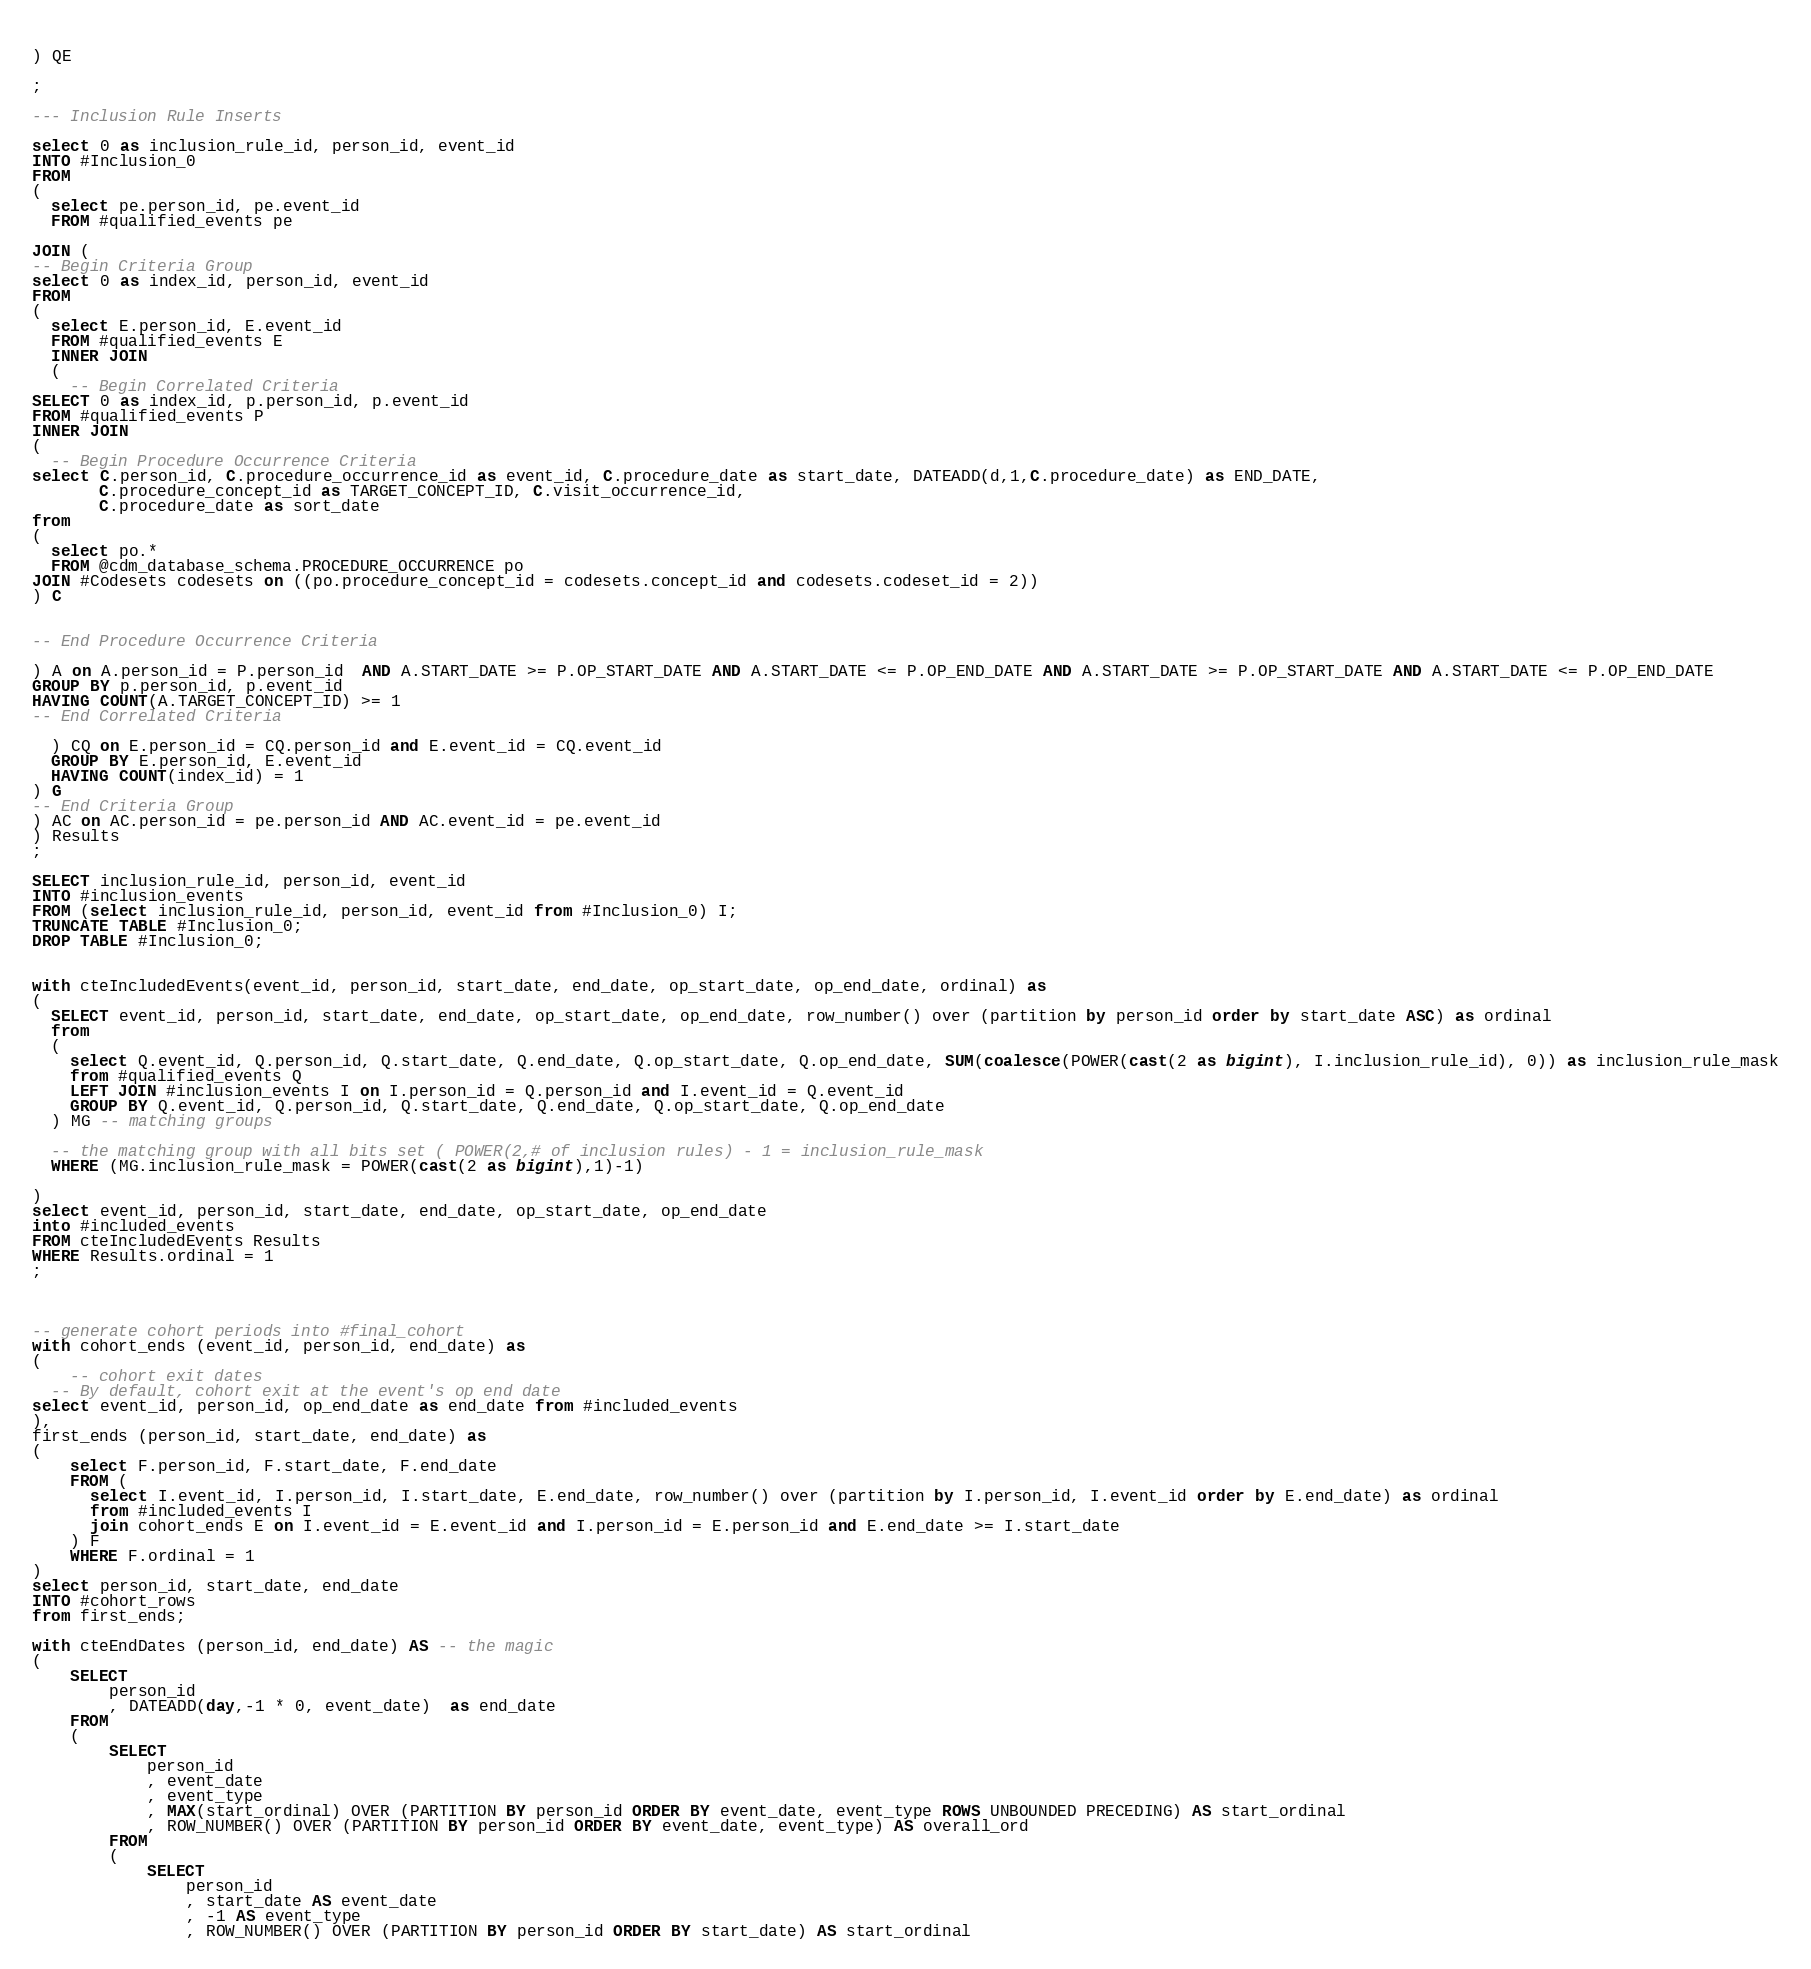Convert code to text. <code><loc_0><loc_0><loc_500><loc_500><_SQL_>  
) QE

;

--- Inclusion Rule Inserts

select 0 as inclusion_rule_id, person_id, event_id
INTO #Inclusion_0
FROM 
(
  select pe.person_id, pe.event_id
  FROM #qualified_events pe
  
JOIN (
-- Begin Criteria Group
select 0 as index_id, person_id, event_id
FROM
(
  select E.person_id, E.event_id 
  FROM #qualified_events E
  INNER JOIN
  (
    -- Begin Correlated Criteria
SELECT 0 as index_id, p.person_id, p.event_id
FROM #qualified_events P
INNER JOIN
(
  -- Begin Procedure Occurrence Criteria
select C.person_id, C.procedure_occurrence_id as event_id, C.procedure_date as start_date, DATEADD(d,1,C.procedure_date) as END_DATE,
       C.procedure_concept_id as TARGET_CONCEPT_ID, C.visit_occurrence_id,
       C.procedure_date as sort_date
from 
(
  select po.* 
  FROM @cdm_database_schema.PROCEDURE_OCCURRENCE po
JOIN #Codesets codesets on ((po.procedure_concept_id = codesets.concept_id and codesets.codeset_id = 2))
) C


-- End Procedure Occurrence Criteria

) A on A.person_id = P.person_id  AND A.START_DATE >= P.OP_START_DATE AND A.START_DATE <= P.OP_END_DATE AND A.START_DATE >= P.OP_START_DATE AND A.START_DATE <= P.OP_END_DATE
GROUP BY p.person_id, p.event_id
HAVING COUNT(A.TARGET_CONCEPT_ID) >= 1
-- End Correlated Criteria

  ) CQ on E.person_id = CQ.person_id and E.event_id = CQ.event_id
  GROUP BY E.person_id, E.event_id
  HAVING COUNT(index_id) = 1
) G
-- End Criteria Group
) AC on AC.person_id = pe.person_id AND AC.event_id = pe.event_id
) Results
;

SELECT inclusion_rule_id, person_id, event_id
INTO #inclusion_events
FROM (select inclusion_rule_id, person_id, event_id from #Inclusion_0) I;
TRUNCATE TABLE #Inclusion_0;
DROP TABLE #Inclusion_0;


with cteIncludedEvents(event_id, person_id, start_date, end_date, op_start_date, op_end_date, ordinal) as
(
  SELECT event_id, person_id, start_date, end_date, op_start_date, op_end_date, row_number() over (partition by person_id order by start_date ASC) as ordinal
  from
  (
    select Q.event_id, Q.person_id, Q.start_date, Q.end_date, Q.op_start_date, Q.op_end_date, SUM(coalesce(POWER(cast(2 as bigint), I.inclusion_rule_id), 0)) as inclusion_rule_mask
    from #qualified_events Q
    LEFT JOIN #inclusion_events I on I.person_id = Q.person_id and I.event_id = Q.event_id
    GROUP BY Q.event_id, Q.person_id, Q.start_date, Q.end_date, Q.op_start_date, Q.op_end_date
  ) MG -- matching groups

  -- the matching group with all bits set ( POWER(2,# of inclusion rules) - 1 = inclusion_rule_mask
  WHERE (MG.inclusion_rule_mask = POWER(cast(2 as bigint),1)-1)

)
select event_id, person_id, start_date, end_date, op_start_date, op_end_date
into #included_events
FROM cteIncludedEvents Results
WHERE Results.ordinal = 1
;



-- generate cohort periods into #final_cohort
with cohort_ends (event_id, person_id, end_date) as
(
	-- cohort exit dates
  -- By default, cohort exit at the event's op end date
select event_id, person_id, op_end_date as end_date from #included_events
),
first_ends (person_id, start_date, end_date) as
(
	select F.person_id, F.start_date, F.end_date
	FROM (
	  select I.event_id, I.person_id, I.start_date, E.end_date, row_number() over (partition by I.person_id, I.event_id order by E.end_date) as ordinal 
	  from #included_events I
	  join cohort_ends E on I.event_id = E.event_id and I.person_id = E.person_id and E.end_date >= I.start_date
	) F
	WHERE F.ordinal = 1
)
select person_id, start_date, end_date
INTO #cohort_rows
from first_ends;

with cteEndDates (person_id, end_date) AS -- the magic
(	
	SELECT
		person_id
		, DATEADD(day,-1 * 0, event_date)  as end_date
	FROM
	(
		SELECT
			person_id
			, event_date
			, event_type
			, MAX(start_ordinal) OVER (PARTITION BY person_id ORDER BY event_date, event_type ROWS UNBOUNDED PRECEDING) AS start_ordinal 
			, ROW_NUMBER() OVER (PARTITION BY person_id ORDER BY event_date, event_type) AS overall_ord
		FROM
		(
			SELECT
				person_id
				, start_date AS event_date
				, -1 AS event_type
				, ROW_NUMBER() OVER (PARTITION BY person_id ORDER BY start_date) AS start_ordinal</code> 